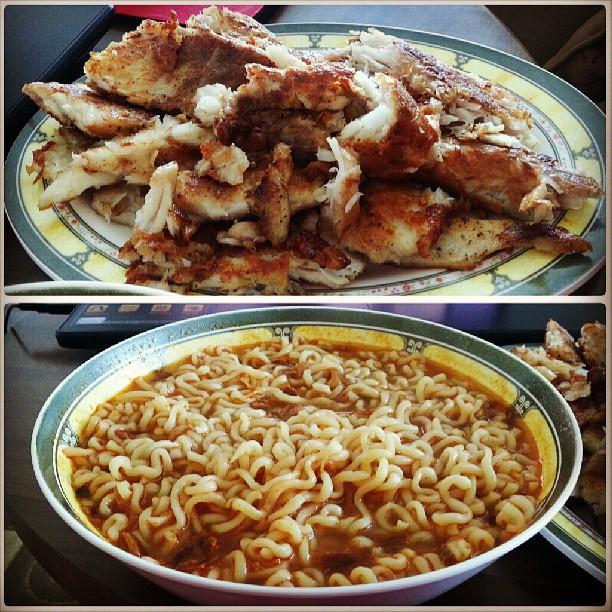Is there meat in this photo?
Short answer required. Yes. What style noodles are in the bowl?
Quick response, please. Ramen. Are the bowl and plate the same color and design?
Short answer required. Yes. 